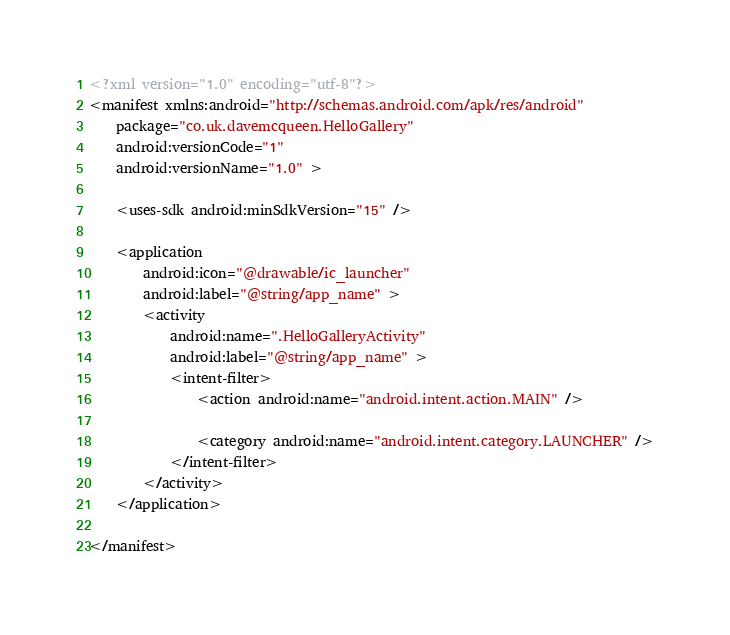<code> <loc_0><loc_0><loc_500><loc_500><_XML_><?xml version="1.0" encoding="utf-8"?>
<manifest xmlns:android="http://schemas.android.com/apk/res/android"
    package="co.uk.davemcqueen.HelloGallery"
    android:versionCode="1"
    android:versionName="1.0" >

    <uses-sdk android:minSdkVersion="15" />

    <application
        android:icon="@drawable/ic_launcher"
        android:label="@string/app_name" >
        <activity
            android:name=".HelloGalleryActivity"
            android:label="@string/app_name" >
            <intent-filter>
                <action android:name="android.intent.action.MAIN" />

                <category android:name="android.intent.category.LAUNCHER" />
            </intent-filter>
        </activity>
    </application>

</manifest></code> 